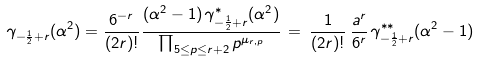<formula> <loc_0><loc_0><loc_500><loc_500>\gamma _ { - \frac { 1 } { 2 } + r } ( \alpha ^ { 2 } ) = \frac { 6 ^ { - r } } { ( 2 r ) ! } \frac { ( \alpha ^ { 2 } - 1 ) \, \gamma _ { - \frac { 1 } { 2 } + r } ^ { \ast } ( \alpha ^ { 2 } ) } { \prod _ { 5 \leq p \leq r + 2 } p ^ { \mu _ { r , p } } } \, = \, \frac { 1 } { ( 2 r ) ! } \, \frac { a ^ { r } } { 6 ^ { r } } \, \gamma _ { - \frac { 1 } { 2 } + r } ^ { \ast \ast } ( \alpha ^ { 2 } - 1 )</formula> 